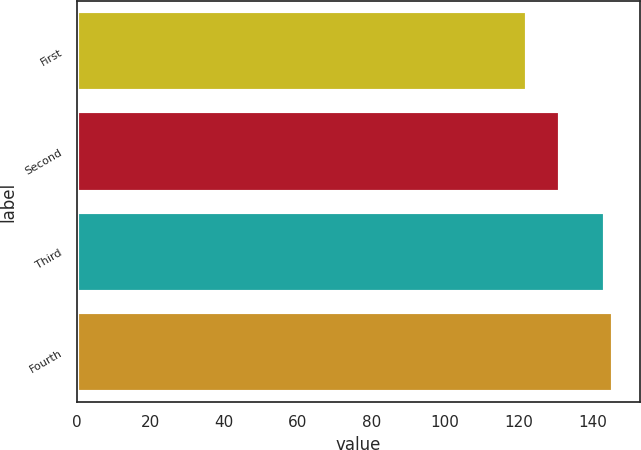Convert chart to OTSL. <chart><loc_0><loc_0><loc_500><loc_500><bar_chart><fcel>First<fcel>Second<fcel>Third<fcel>Fourth<nl><fcel>122.38<fcel>131.3<fcel>143.43<fcel>145.56<nl></chart> 